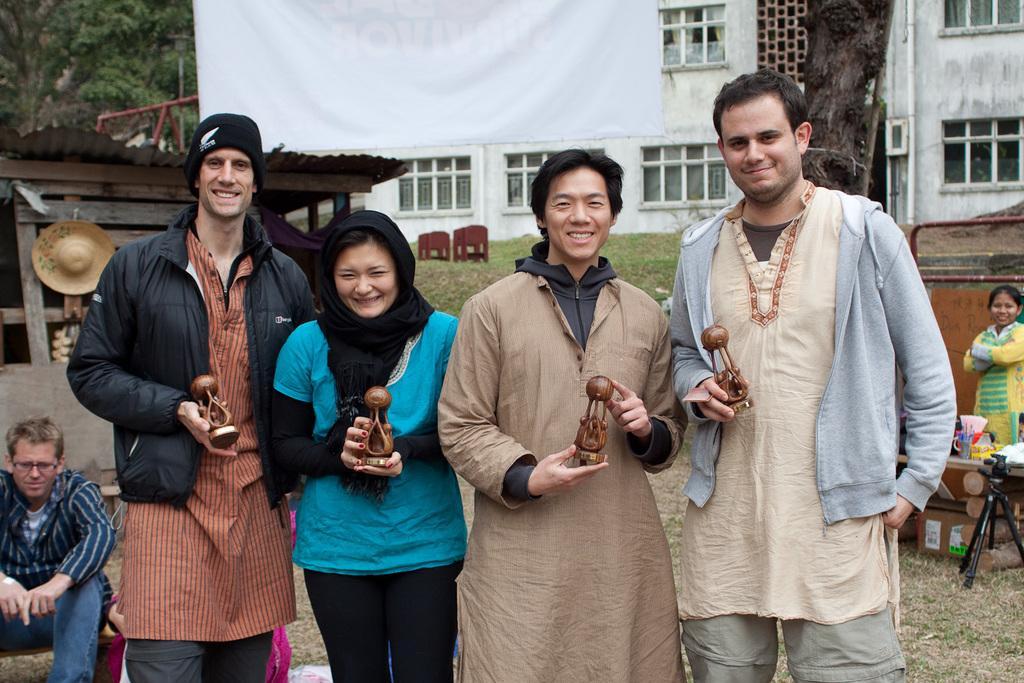How would you summarize this image in a sentence or two? There are four persons standing and holding an object in their hands and there are few person's,a building and trees in the background. 